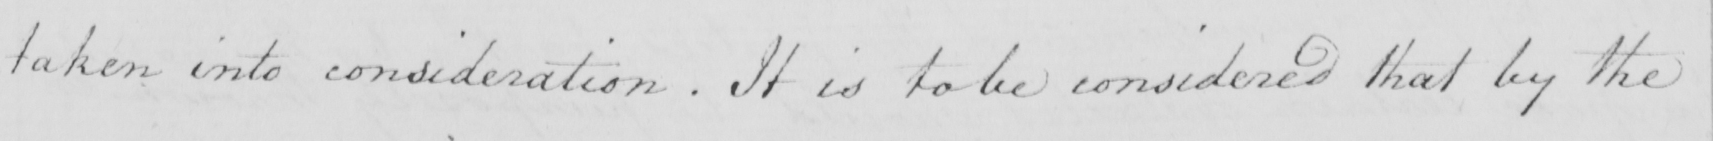Please transcribe the handwritten text in this image. taken into consideration . If it is to be considered that by the 